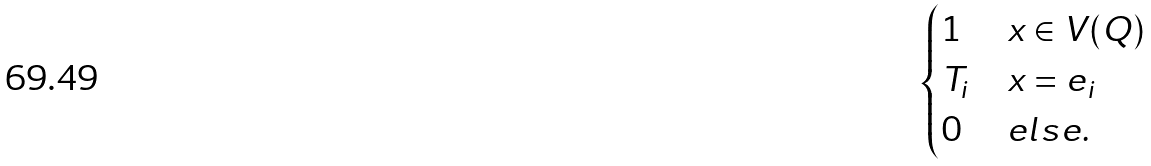<formula> <loc_0><loc_0><loc_500><loc_500>\begin{cases} 1 & x \in V ( Q ) \\ T _ { i } & x = e _ { i } \\ 0 & e l s e . \end{cases}</formula> 